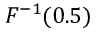<formula> <loc_0><loc_0><loc_500><loc_500>F ^ { - 1 } ( 0 . 5 )</formula> 